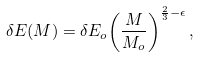Convert formula to latex. <formula><loc_0><loc_0><loc_500><loc_500>\delta E ( M ) = \delta E _ { o } { \left ( \frac { M } { M _ { o } } \right ) } ^ { \frac { 2 } { 3 } - \epsilon } \, ,</formula> 